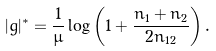Convert formula to latex. <formula><loc_0><loc_0><loc_500><loc_500>| g | ^ { * } = \frac { 1 } { \mu } \log \left ( 1 + \frac { n _ { 1 } + n _ { 2 } } { 2 n _ { 1 2 } } \right ) .</formula> 